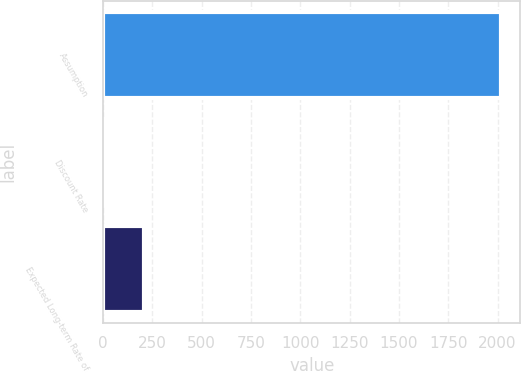Convert chart to OTSL. <chart><loc_0><loc_0><loc_500><loc_500><bar_chart><fcel>Assumption<fcel>Discount Rate<fcel>Expected Long-term Rate of<nl><fcel>2015<fcel>4.4<fcel>205.46<nl></chart> 